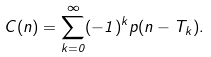Convert formula to latex. <formula><loc_0><loc_0><loc_500><loc_500>C ( n ) = \sum _ { k = 0 } ^ { \infty } ( - 1 ) ^ { k } p ( n - T _ { k } ) .</formula> 